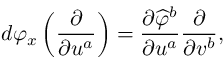Convert formula to latex. <formula><loc_0><loc_0><loc_500><loc_500>d \varphi _ { x } \left ( { \frac { \partial } { \partial u ^ { a } } } \right ) = { \frac { \partial { \widehat { \varphi } } ^ { b } } { \partial u ^ { a } } } { \frac { \partial } { \partial v ^ { b } } } ,</formula> 